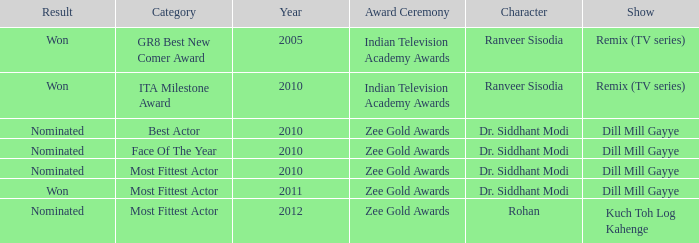Which show has a character of Rohan? Kuch Toh Log Kahenge. 